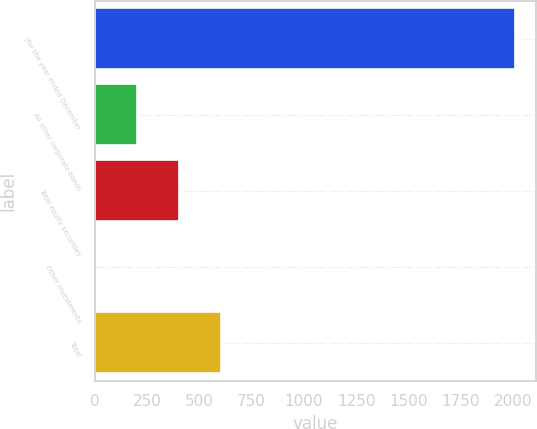<chart> <loc_0><loc_0><loc_500><loc_500><bar_chart><fcel>(for the year ended December<fcel>All other corporate bonds<fcel>Total equity securities<fcel>Other investments<fcel>Total<nl><fcel>2011<fcel>202<fcel>403<fcel>1<fcel>604<nl></chart> 